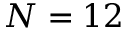Convert formula to latex. <formula><loc_0><loc_0><loc_500><loc_500>N = 1 2</formula> 